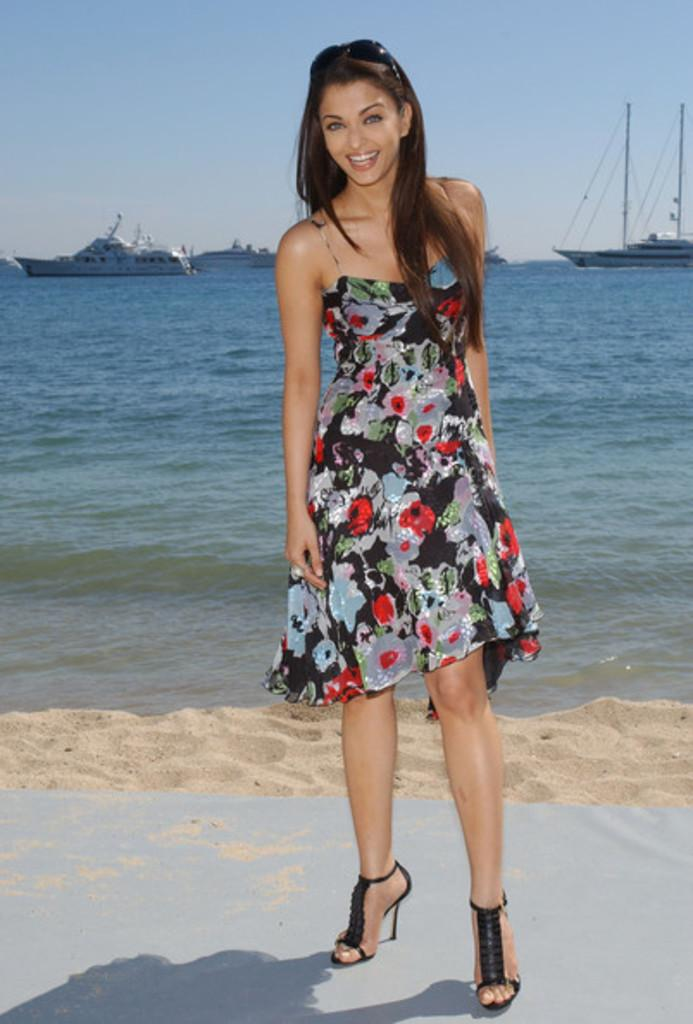What is the main subject of the image? There is a person in the image. How is the person positioned in relation to the other elements? The person is in front of the other elements. What type of terrain is visible behind the person? There is sand behind the person. What can be seen in the background of the image? There are ships in the water in the background of the image. What is visible at the top of the image? The sky is visible at the top of the image. What type of school can be seen in the image? There is no school present in the image. How does the person's nerve affect their ability to interact with the sand in the image? There is no information about the person's nerve in the image, and it does not affect their interaction with the sand. 